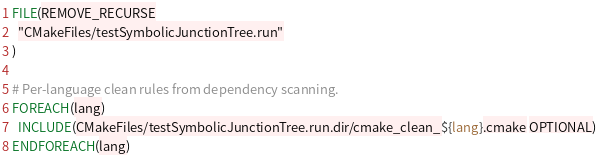<code> <loc_0><loc_0><loc_500><loc_500><_CMake_>FILE(REMOVE_RECURSE
  "CMakeFiles/testSymbolicJunctionTree.run"
)

# Per-language clean rules from dependency scanning.
FOREACH(lang)
  INCLUDE(CMakeFiles/testSymbolicJunctionTree.run.dir/cmake_clean_${lang}.cmake OPTIONAL)
ENDFOREACH(lang)
</code> 